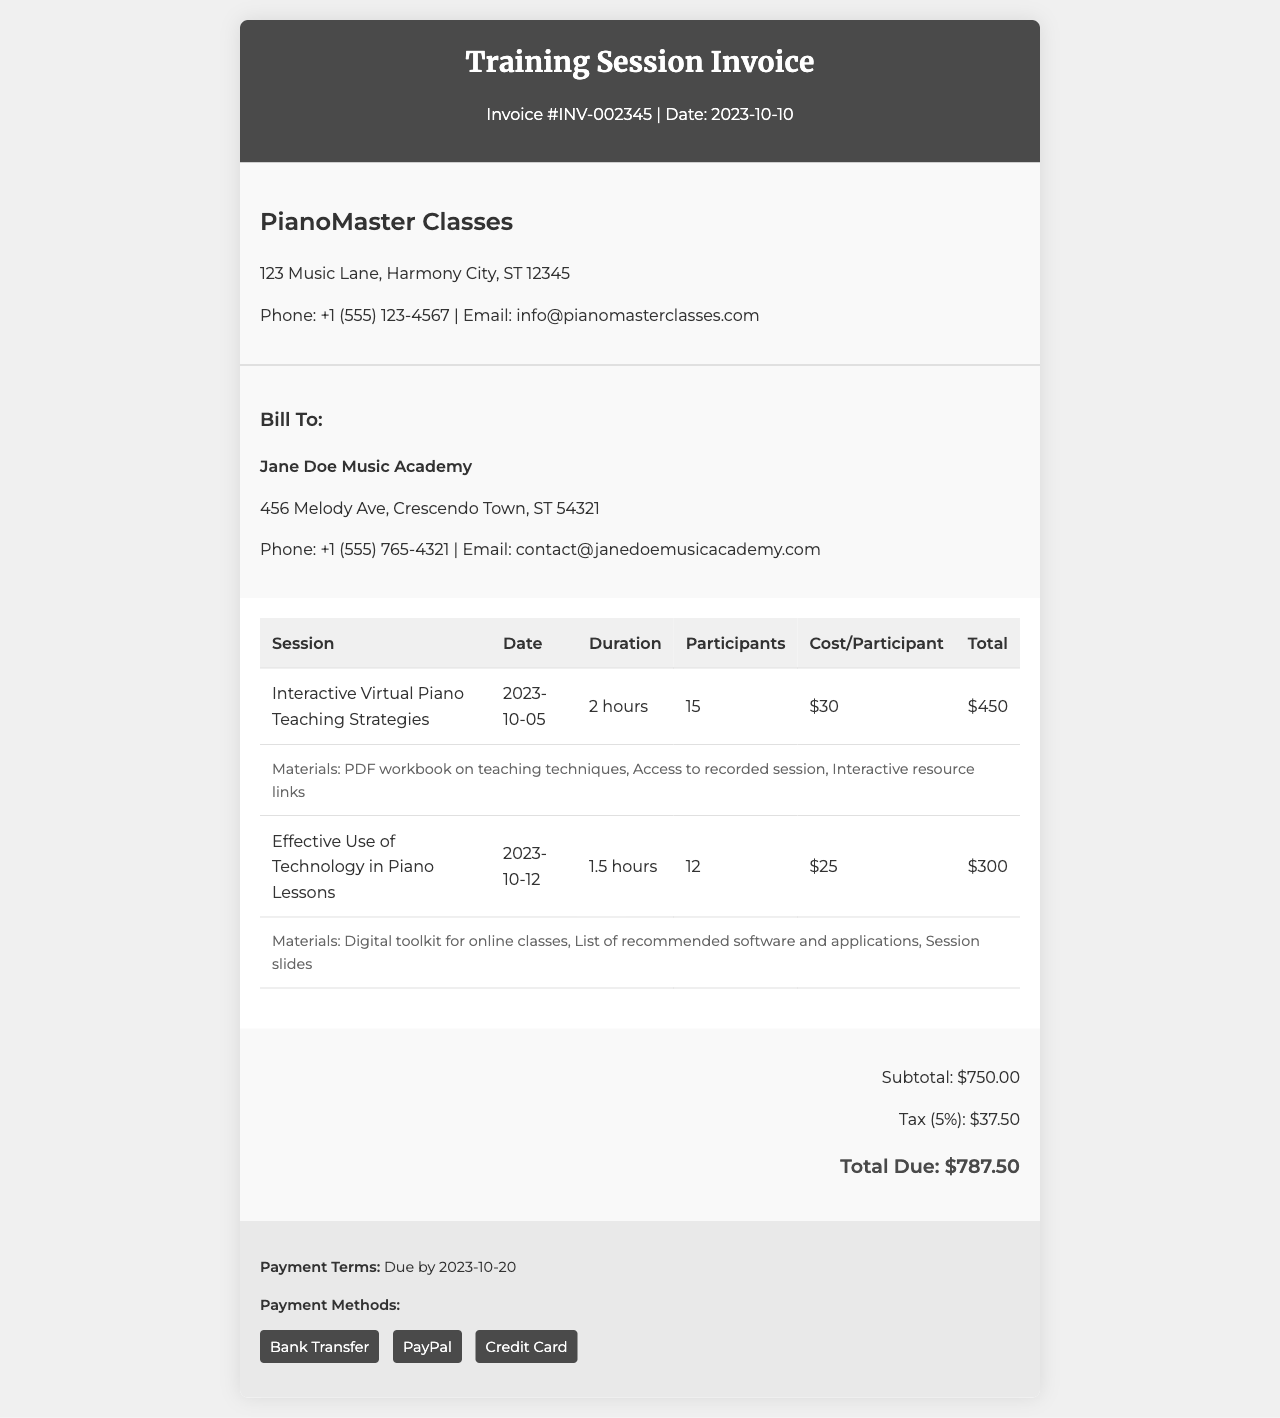What is the invoice number? The invoice number is clearly stated at the top of the document as Invoice #INV-002345.
Answer: INV-002345 What is the date of the invoice? The date is indicated next to the invoice number, which is 2023-10-10.
Answer: 2023-10-10 How many participants attended the first session? The number of participants is shown in the table under the first session, which lists 15 participants.
Answer: 15 What is the total cost for the first session? The total cost for the first session is specified in the last column of the first row as $450.
Answer: $450 What materials were provided for the second session? The materials for the second session are listed in the document as a digital toolkit for online classes, a list of recommended software and applications, and session slides.
Answer: Digital toolkit for online classes, List of recommended software and applications, Session slides What is the subtotal of the invoice? The subtotal is indicated in the invoice summary section as $750.00.
Answer: $750.00 What is the due date for payment? The due date is outlined in the payment terms section as 2023-10-20.
Answer: 2023-10-20 What is the total amount due? The total amount due is specified in the summary section as $787.50.
Answer: $787.50 How many sessions are detailed in the invoice? The document contains two detailed sessions as shown in the session details table.
Answer: 2 